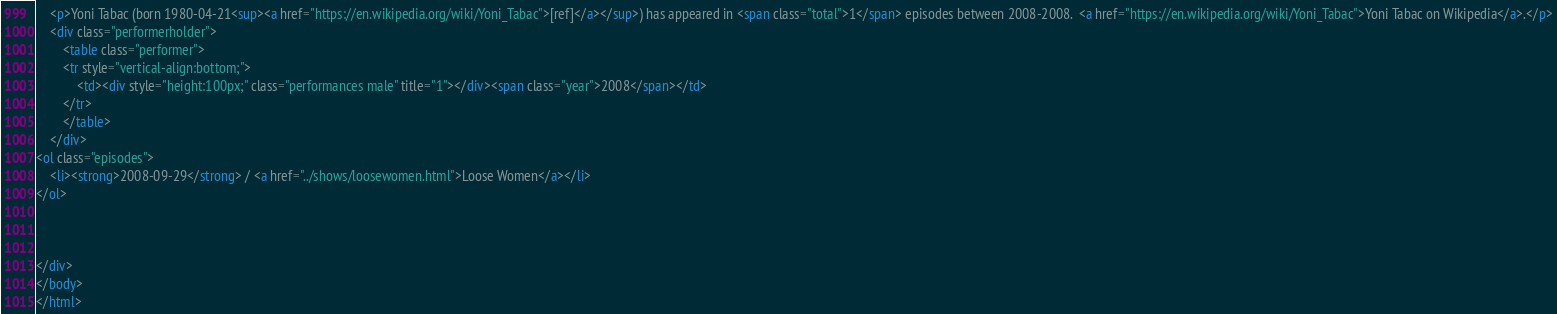<code> <loc_0><loc_0><loc_500><loc_500><_HTML_>	<p>Yoni Tabac (born 1980-04-21<sup><a href="https://en.wikipedia.org/wiki/Yoni_Tabac">[ref]</a></sup>) has appeared in <span class="total">1</span> episodes between 2008-2008.  <a href="https://en.wikipedia.org/wiki/Yoni_Tabac">Yoni Tabac on Wikipedia</a>.</p>
	<div class="performerholder">
		<table class="performer">
		<tr style="vertical-align:bottom;">
			<td><div style="height:100px;" class="performances male" title="1"></div><span class="year">2008</span></td>
		</tr>
		</table>
	</div>
<ol class="episodes">
	<li><strong>2008-09-29</strong> / <a href="../shows/loosewomen.html">Loose Women</a></li>
</ol>



</div>
</body>
</html>
</code> 